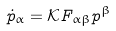Convert formula to latex. <formula><loc_0><loc_0><loc_500><loc_500>\dot { p } _ { \alpha } = \mathcal { K } F _ { \alpha \beta } p ^ { \beta }</formula> 